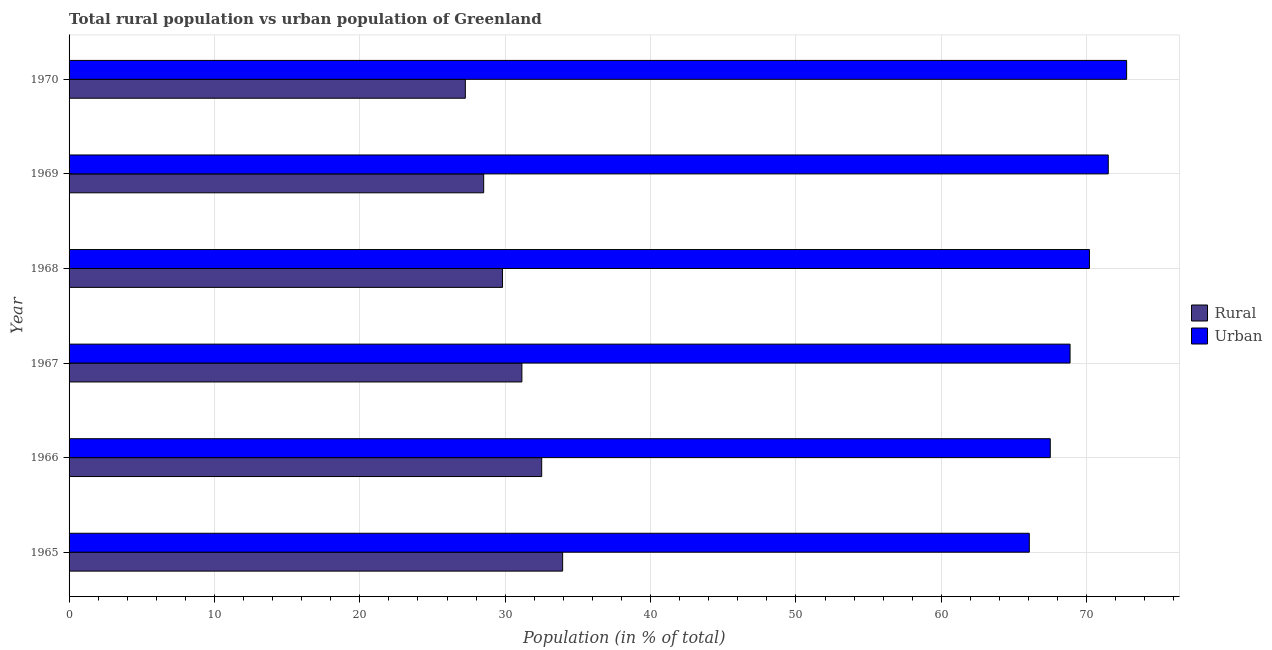How many different coloured bars are there?
Provide a succinct answer. 2. How many groups of bars are there?
Your answer should be very brief. 6. Are the number of bars per tick equal to the number of legend labels?
Offer a terse response. Yes. What is the label of the 4th group of bars from the top?
Your response must be concise. 1967. In how many cases, is the number of bars for a given year not equal to the number of legend labels?
Your response must be concise. 0. What is the urban population in 1967?
Provide a succinct answer. 68.85. Across all years, what is the maximum urban population?
Offer a terse response. 72.74. Across all years, what is the minimum rural population?
Provide a succinct answer. 27.26. In which year was the rural population maximum?
Keep it short and to the point. 1965. What is the total urban population in the graph?
Your answer should be very brief. 416.81. What is the difference between the rural population in 1967 and that in 1970?
Give a very brief answer. 3.89. What is the difference between the urban population in 1969 and the rural population in 1965?
Your response must be concise. 37.53. What is the average urban population per year?
Your response must be concise. 69.47. In the year 1967, what is the difference between the urban population and rural population?
Your response must be concise. 37.71. In how many years, is the rural population greater than 48 %?
Keep it short and to the point. 0. What is the ratio of the rural population in 1966 to that in 1970?
Offer a terse response. 1.19. Is the urban population in 1967 less than that in 1968?
Make the answer very short. Yes. Is the difference between the urban population in 1965 and 1966 greater than the difference between the rural population in 1965 and 1966?
Provide a succinct answer. No. What is the difference between the highest and the second highest urban population?
Ensure brevity in your answer.  1.26. What is the difference between the highest and the lowest urban population?
Your response must be concise. 6.69. Is the sum of the urban population in 1966 and 1967 greater than the maximum rural population across all years?
Give a very brief answer. Yes. What does the 2nd bar from the top in 1969 represents?
Give a very brief answer. Rural. What does the 2nd bar from the bottom in 1968 represents?
Offer a very short reply. Urban. Does the graph contain any zero values?
Provide a succinct answer. No. Does the graph contain grids?
Your answer should be compact. Yes. Where does the legend appear in the graph?
Your response must be concise. Center right. How are the legend labels stacked?
Offer a very short reply. Vertical. What is the title of the graph?
Provide a succinct answer. Total rural population vs urban population of Greenland. Does "Male labourers" appear as one of the legend labels in the graph?
Ensure brevity in your answer.  No. What is the label or title of the X-axis?
Offer a terse response. Population (in % of total). What is the Population (in % of total) of Rural in 1965?
Your response must be concise. 33.95. What is the Population (in % of total) of Urban in 1965?
Offer a terse response. 66.05. What is the Population (in % of total) of Rural in 1966?
Your response must be concise. 32.51. What is the Population (in % of total) in Urban in 1966?
Offer a very short reply. 67.49. What is the Population (in % of total) of Rural in 1967?
Keep it short and to the point. 31.15. What is the Population (in % of total) in Urban in 1967?
Make the answer very short. 68.85. What is the Population (in % of total) in Rural in 1968?
Provide a short and direct response. 29.81. What is the Population (in % of total) of Urban in 1968?
Provide a succinct answer. 70.19. What is the Population (in % of total) of Rural in 1969?
Give a very brief answer. 28.52. What is the Population (in % of total) in Urban in 1969?
Keep it short and to the point. 71.48. What is the Population (in % of total) in Rural in 1970?
Provide a succinct answer. 27.26. What is the Population (in % of total) in Urban in 1970?
Provide a short and direct response. 72.74. Across all years, what is the maximum Population (in % of total) of Rural?
Your response must be concise. 33.95. Across all years, what is the maximum Population (in % of total) in Urban?
Provide a succinct answer. 72.74. Across all years, what is the minimum Population (in % of total) of Rural?
Ensure brevity in your answer.  27.26. Across all years, what is the minimum Population (in % of total) of Urban?
Provide a succinct answer. 66.05. What is the total Population (in % of total) in Rural in the graph?
Your response must be concise. 183.19. What is the total Population (in % of total) in Urban in the graph?
Ensure brevity in your answer.  416.81. What is the difference between the Population (in % of total) in Rural in 1965 and that in 1966?
Your answer should be compact. 1.44. What is the difference between the Population (in % of total) of Urban in 1965 and that in 1966?
Your answer should be very brief. -1.44. What is the difference between the Population (in % of total) of Rural in 1965 and that in 1967?
Keep it short and to the point. 2.8. What is the difference between the Population (in % of total) of Urban in 1965 and that in 1967?
Make the answer very short. -2.8. What is the difference between the Population (in % of total) in Rural in 1965 and that in 1968?
Provide a short and direct response. 4.14. What is the difference between the Population (in % of total) in Urban in 1965 and that in 1968?
Give a very brief answer. -4.14. What is the difference between the Population (in % of total) of Rural in 1965 and that in 1969?
Offer a very short reply. 5.43. What is the difference between the Population (in % of total) in Urban in 1965 and that in 1969?
Your answer should be compact. -5.43. What is the difference between the Population (in % of total) of Rural in 1965 and that in 1970?
Make the answer very short. 6.69. What is the difference between the Population (in % of total) in Urban in 1965 and that in 1970?
Ensure brevity in your answer.  -6.69. What is the difference between the Population (in % of total) of Rural in 1966 and that in 1967?
Give a very brief answer. 1.36. What is the difference between the Population (in % of total) in Urban in 1966 and that in 1967?
Ensure brevity in your answer.  -1.36. What is the difference between the Population (in % of total) of Rural in 1966 and that in 1968?
Give a very brief answer. 2.69. What is the difference between the Population (in % of total) in Urban in 1966 and that in 1968?
Offer a very short reply. -2.69. What is the difference between the Population (in % of total) of Rural in 1966 and that in 1969?
Your answer should be compact. 3.99. What is the difference between the Population (in % of total) in Urban in 1966 and that in 1969?
Keep it short and to the point. -3.99. What is the difference between the Population (in % of total) of Rural in 1966 and that in 1970?
Your answer should be very brief. 5.25. What is the difference between the Population (in % of total) of Urban in 1966 and that in 1970?
Ensure brevity in your answer.  -5.25. What is the difference between the Population (in % of total) in Rural in 1967 and that in 1968?
Provide a short and direct response. 1.33. What is the difference between the Population (in % of total) in Urban in 1967 and that in 1968?
Make the answer very short. -1.33. What is the difference between the Population (in % of total) of Rural in 1967 and that in 1969?
Keep it short and to the point. 2.63. What is the difference between the Population (in % of total) in Urban in 1967 and that in 1969?
Ensure brevity in your answer.  -2.63. What is the difference between the Population (in % of total) of Rural in 1967 and that in 1970?
Your response must be concise. 3.89. What is the difference between the Population (in % of total) of Urban in 1967 and that in 1970?
Your answer should be very brief. -3.89. What is the difference between the Population (in % of total) of Rural in 1968 and that in 1969?
Offer a very short reply. 1.29. What is the difference between the Population (in % of total) in Urban in 1968 and that in 1969?
Give a very brief answer. -1.29. What is the difference between the Population (in % of total) of Rural in 1968 and that in 1970?
Give a very brief answer. 2.56. What is the difference between the Population (in % of total) of Urban in 1968 and that in 1970?
Offer a very short reply. -2.56. What is the difference between the Population (in % of total) in Rural in 1969 and that in 1970?
Provide a succinct answer. 1.26. What is the difference between the Population (in % of total) of Urban in 1969 and that in 1970?
Keep it short and to the point. -1.26. What is the difference between the Population (in % of total) of Rural in 1965 and the Population (in % of total) of Urban in 1966?
Your response must be concise. -33.54. What is the difference between the Population (in % of total) in Rural in 1965 and the Population (in % of total) in Urban in 1967?
Provide a short and direct response. -34.9. What is the difference between the Population (in % of total) of Rural in 1965 and the Population (in % of total) of Urban in 1968?
Make the answer very short. -36.24. What is the difference between the Population (in % of total) of Rural in 1965 and the Population (in % of total) of Urban in 1969?
Your answer should be compact. -37.53. What is the difference between the Population (in % of total) of Rural in 1965 and the Population (in % of total) of Urban in 1970?
Your answer should be very brief. -38.79. What is the difference between the Population (in % of total) of Rural in 1966 and the Population (in % of total) of Urban in 1967?
Offer a terse response. -36.34. What is the difference between the Population (in % of total) of Rural in 1966 and the Population (in % of total) of Urban in 1968?
Give a very brief answer. -37.68. What is the difference between the Population (in % of total) in Rural in 1966 and the Population (in % of total) in Urban in 1969?
Provide a short and direct response. -38.97. What is the difference between the Population (in % of total) of Rural in 1966 and the Population (in % of total) of Urban in 1970?
Provide a short and direct response. -40.23. What is the difference between the Population (in % of total) in Rural in 1967 and the Population (in % of total) in Urban in 1968?
Your answer should be compact. -39.04. What is the difference between the Population (in % of total) in Rural in 1967 and the Population (in % of total) in Urban in 1969?
Ensure brevity in your answer.  -40.33. What is the difference between the Population (in % of total) in Rural in 1967 and the Population (in % of total) in Urban in 1970?
Your response must be concise. -41.6. What is the difference between the Population (in % of total) in Rural in 1968 and the Population (in % of total) in Urban in 1969?
Provide a short and direct response. -41.67. What is the difference between the Population (in % of total) of Rural in 1968 and the Population (in % of total) of Urban in 1970?
Keep it short and to the point. -42.93. What is the difference between the Population (in % of total) in Rural in 1969 and the Population (in % of total) in Urban in 1970?
Keep it short and to the point. -44.23. What is the average Population (in % of total) of Rural per year?
Offer a very short reply. 30.53. What is the average Population (in % of total) of Urban per year?
Offer a very short reply. 69.47. In the year 1965, what is the difference between the Population (in % of total) of Rural and Population (in % of total) of Urban?
Keep it short and to the point. -32.1. In the year 1966, what is the difference between the Population (in % of total) in Rural and Population (in % of total) in Urban?
Ensure brevity in your answer.  -34.98. In the year 1967, what is the difference between the Population (in % of total) of Rural and Population (in % of total) of Urban?
Keep it short and to the point. -37.71. In the year 1968, what is the difference between the Population (in % of total) of Rural and Population (in % of total) of Urban?
Provide a succinct answer. -40.37. In the year 1969, what is the difference between the Population (in % of total) of Rural and Population (in % of total) of Urban?
Your response must be concise. -42.96. In the year 1970, what is the difference between the Population (in % of total) in Rural and Population (in % of total) in Urban?
Offer a terse response. -45.49. What is the ratio of the Population (in % of total) of Rural in 1965 to that in 1966?
Offer a very short reply. 1.04. What is the ratio of the Population (in % of total) in Urban in 1965 to that in 1966?
Make the answer very short. 0.98. What is the ratio of the Population (in % of total) of Rural in 1965 to that in 1967?
Keep it short and to the point. 1.09. What is the ratio of the Population (in % of total) of Urban in 1965 to that in 1967?
Ensure brevity in your answer.  0.96. What is the ratio of the Population (in % of total) of Rural in 1965 to that in 1968?
Ensure brevity in your answer.  1.14. What is the ratio of the Population (in % of total) of Urban in 1965 to that in 1968?
Your answer should be compact. 0.94. What is the ratio of the Population (in % of total) in Rural in 1965 to that in 1969?
Give a very brief answer. 1.19. What is the ratio of the Population (in % of total) of Urban in 1965 to that in 1969?
Provide a succinct answer. 0.92. What is the ratio of the Population (in % of total) of Rural in 1965 to that in 1970?
Your answer should be compact. 1.25. What is the ratio of the Population (in % of total) of Urban in 1965 to that in 1970?
Your answer should be very brief. 0.91. What is the ratio of the Population (in % of total) in Rural in 1966 to that in 1967?
Give a very brief answer. 1.04. What is the ratio of the Population (in % of total) in Urban in 1966 to that in 1967?
Offer a very short reply. 0.98. What is the ratio of the Population (in % of total) of Rural in 1966 to that in 1968?
Keep it short and to the point. 1.09. What is the ratio of the Population (in % of total) in Urban in 1966 to that in 1968?
Your answer should be compact. 0.96. What is the ratio of the Population (in % of total) of Rural in 1966 to that in 1969?
Your answer should be very brief. 1.14. What is the ratio of the Population (in % of total) of Urban in 1966 to that in 1969?
Your answer should be very brief. 0.94. What is the ratio of the Population (in % of total) in Rural in 1966 to that in 1970?
Offer a very short reply. 1.19. What is the ratio of the Population (in % of total) of Urban in 1966 to that in 1970?
Give a very brief answer. 0.93. What is the ratio of the Population (in % of total) in Rural in 1967 to that in 1968?
Your answer should be very brief. 1.04. What is the ratio of the Population (in % of total) of Urban in 1967 to that in 1968?
Provide a short and direct response. 0.98. What is the ratio of the Population (in % of total) in Rural in 1967 to that in 1969?
Provide a short and direct response. 1.09. What is the ratio of the Population (in % of total) of Urban in 1967 to that in 1969?
Your response must be concise. 0.96. What is the ratio of the Population (in % of total) of Rural in 1967 to that in 1970?
Provide a succinct answer. 1.14. What is the ratio of the Population (in % of total) in Urban in 1967 to that in 1970?
Your response must be concise. 0.95. What is the ratio of the Population (in % of total) of Rural in 1968 to that in 1969?
Offer a very short reply. 1.05. What is the ratio of the Population (in % of total) of Urban in 1968 to that in 1969?
Ensure brevity in your answer.  0.98. What is the ratio of the Population (in % of total) in Rural in 1968 to that in 1970?
Keep it short and to the point. 1.09. What is the ratio of the Population (in % of total) in Urban in 1968 to that in 1970?
Offer a very short reply. 0.96. What is the ratio of the Population (in % of total) in Rural in 1969 to that in 1970?
Offer a very short reply. 1.05. What is the ratio of the Population (in % of total) in Urban in 1969 to that in 1970?
Your answer should be compact. 0.98. What is the difference between the highest and the second highest Population (in % of total) of Rural?
Your response must be concise. 1.44. What is the difference between the highest and the second highest Population (in % of total) of Urban?
Make the answer very short. 1.26. What is the difference between the highest and the lowest Population (in % of total) in Rural?
Give a very brief answer. 6.69. What is the difference between the highest and the lowest Population (in % of total) in Urban?
Make the answer very short. 6.69. 